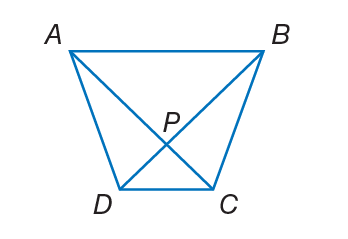Question: A B C D is a trapezoid. If m \angle A B C = 4 x + 11 and m \angle D A B = 2 x + 33, find the value of x so that A B C D is isosceles.
Choices:
A. 11
B. 30
C. 44
D. 55
Answer with the letter. Answer: A Question: A B C D is a trapezoid. If A C = 3 x - 7 and B D = 2 x + 8, find the value of x so that A B C D is isosceles.
Choices:
A. 15
B. 20
C. 28
D. 38
Answer with the letter. Answer: A 